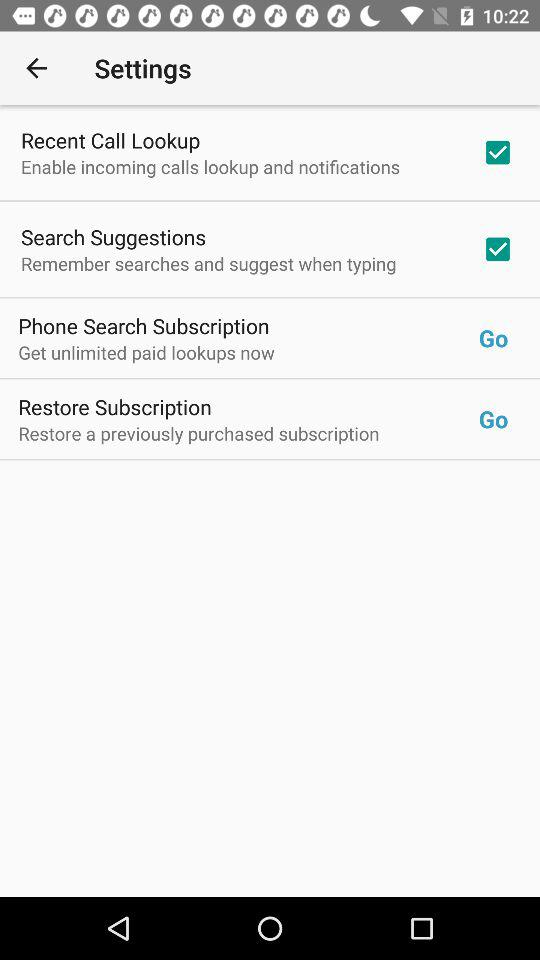What is the current status of the "Search Suggestions"? The current status is "on". 